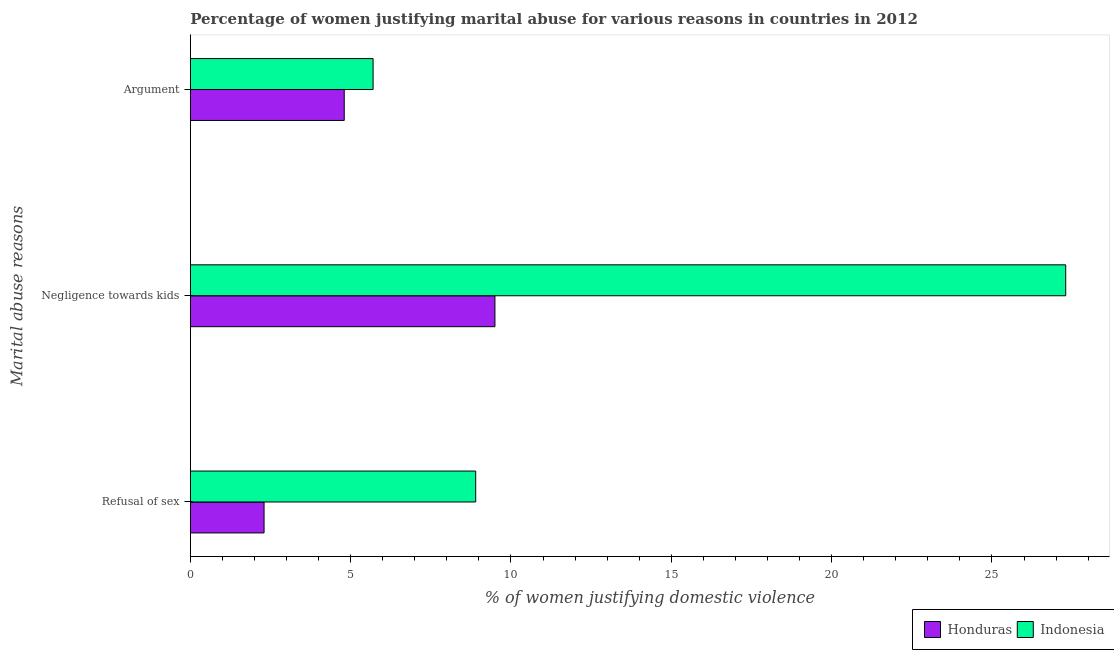How many different coloured bars are there?
Provide a succinct answer. 2. Are the number of bars per tick equal to the number of legend labels?
Give a very brief answer. Yes. How many bars are there on the 3rd tick from the bottom?
Make the answer very short. 2. What is the label of the 2nd group of bars from the top?
Your response must be concise. Negligence towards kids. What is the percentage of women justifying domestic violence due to refusal of sex in Indonesia?
Keep it short and to the point. 8.9. Across all countries, what is the minimum percentage of women justifying domestic violence due to refusal of sex?
Provide a short and direct response. 2.3. In which country was the percentage of women justifying domestic violence due to arguments minimum?
Provide a succinct answer. Honduras. What is the total percentage of women justifying domestic violence due to negligence towards kids in the graph?
Give a very brief answer. 36.8. What is the difference between the percentage of women justifying domestic violence due to negligence towards kids in Indonesia and that in Honduras?
Provide a succinct answer. 17.8. What is the difference between the percentage of women justifying domestic violence due to refusal of sex in Honduras and the percentage of women justifying domestic violence due to arguments in Indonesia?
Your response must be concise. -3.4. What is the average percentage of women justifying domestic violence due to negligence towards kids per country?
Keep it short and to the point. 18.4. What is the difference between the percentage of women justifying domestic violence due to arguments and percentage of women justifying domestic violence due to negligence towards kids in Indonesia?
Provide a short and direct response. -21.6. What is the ratio of the percentage of women justifying domestic violence due to arguments in Honduras to that in Indonesia?
Make the answer very short. 0.84. Is the percentage of women justifying domestic violence due to refusal of sex in Indonesia less than that in Honduras?
Your response must be concise. No. What is the difference between the highest and the lowest percentage of women justifying domestic violence due to refusal of sex?
Ensure brevity in your answer.  6.6. Is the sum of the percentage of women justifying domestic violence due to negligence towards kids in Honduras and Indonesia greater than the maximum percentage of women justifying domestic violence due to refusal of sex across all countries?
Provide a succinct answer. Yes. What does the 2nd bar from the top in Argument represents?
Keep it short and to the point. Honduras. What does the 2nd bar from the bottom in Refusal of sex represents?
Keep it short and to the point. Indonesia. How many bars are there?
Your response must be concise. 6. Are all the bars in the graph horizontal?
Offer a terse response. Yes. How many countries are there in the graph?
Make the answer very short. 2. What is the difference between two consecutive major ticks on the X-axis?
Offer a very short reply. 5. Are the values on the major ticks of X-axis written in scientific E-notation?
Make the answer very short. No. What is the title of the graph?
Keep it short and to the point. Percentage of women justifying marital abuse for various reasons in countries in 2012. Does "Czech Republic" appear as one of the legend labels in the graph?
Keep it short and to the point. No. What is the label or title of the X-axis?
Offer a very short reply. % of women justifying domestic violence. What is the label or title of the Y-axis?
Give a very brief answer. Marital abuse reasons. What is the % of women justifying domestic violence in Honduras in Negligence towards kids?
Your answer should be very brief. 9.5. What is the % of women justifying domestic violence of Indonesia in Negligence towards kids?
Keep it short and to the point. 27.3. What is the % of women justifying domestic violence of Indonesia in Argument?
Offer a terse response. 5.7. Across all Marital abuse reasons, what is the maximum % of women justifying domestic violence in Indonesia?
Offer a very short reply. 27.3. Across all Marital abuse reasons, what is the minimum % of women justifying domestic violence in Indonesia?
Your answer should be compact. 5.7. What is the total % of women justifying domestic violence in Honduras in the graph?
Give a very brief answer. 16.6. What is the total % of women justifying domestic violence in Indonesia in the graph?
Offer a very short reply. 41.9. What is the difference between the % of women justifying domestic violence of Indonesia in Refusal of sex and that in Negligence towards kids?
Your answer should be compact. -18.4. What is the difference between the % of women justifying domestic violence of Honduras in Refusal of sex and that in Argument?
Your response must be concise. -2.5. What is the difference between the % of women justifying domestic violence in Indonesia in Refusal of sex and that in Argument?
Your answer should be compact. 3.2. What is the difference between the % of women justifying domestic violence of Indonesia in Negligence towards kids and that in Argument?
Make the answer very short. 21.6. What is the difference between the % of women justifying domestic violence in Honduras in Refusal of sex and the % of women justifying domestic violence in Indonesia in Negligence towards kids?
Keep it short and to the point. -25. What is the difference between the % of women justifying domestic violence in Honduras in Negligence towards kids and the % of women justifying domestic violence in Indonesia in Argument?
Ensure brevity in your answer.  3.8. What is the average % of women justifying domestic violence of Honduras per Marital abuse reasons?
Provide a succinct answer. 5.53. What is the average % of women justifying domestic violence of Indonesia per Marital abuse reasons?
Your answer should be very brief. 13.97. What is the difference between the % of women justifying domestic violence in Honduras and % of women justifying domestic violence in Indonesia in Negligence towards kids?
Give a very brief answer. -17.8. What is the ratio of the % of women justifying domestic violence in Honduras in Refusal of sex to that in Negligence towards kids?
Ensure brevity in your answer.  0.24. What is the ratio of the % of women justifying domestic violence in Indonesia in Refusal of sex to that in Negligence towards kids?
Give a very brief answer. 0.33. What is the ratio of the % of women justifying domestic violence in Honduras in Refusal of sex to that in Argument?
Give a very brief answer. 0.48. What is the ratio of the % of women justifying domestic violence in Indonesia in Refusal of sex to that in Argument?
Provide a succinct answer. 1.56. What is the ratio of the % of women justifying domestic violence in Honduras in Negligence towards kids to that in Argument?
Provide a short and direct response. 1.98. What is the ratio of the % of women justifying domestic violence in Indonesia in Negligence towards kids to that in Argument?
Your response must be concise. 4.79. What is the difference between the highest and the second highest % of women justifying domestic violence of Indonesia?
Your answer should be very brief. 18.4. What is the difference between the highest and the lowest % of women justifying domestic violence of Honduras?
Your answer should be very brief. 7.2. What is the difference between the highest and the lowest % of women justifying domestic violence of Indonesia?
Provide a short and direct response. 21.6. 